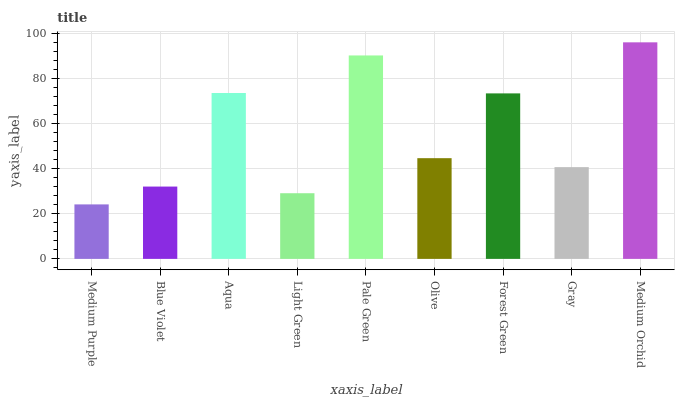Is Medium Purple the minimum?
Answer yes or no. Yes. Is Medium Orchid the maximum?
Answer yes or no. Yes. Is Blue Violet the minimum?
Answer yes or no. No. Is Blue Violet the maximum?
Answer yes or no. No. Is Blue Violet greater than Medium Purple?
Answer yes or no. Yes. Is Medium Purple less than Blue Violet?
Answer yes or no. Yes. Is Medium Purple greater than Blue Violet?
Answer yes or no. No. Is Blue Violet less than Medium Purple?
Answer yes or no. No. Is Olive the high median?
Answer yes or no. Yes. Is Olive the low median?
Answer yes or no. Yes. Is Light Green the high median?
Answer yes or no. No. Is Medium Orchid the low median?
Answer yes or no. No. 